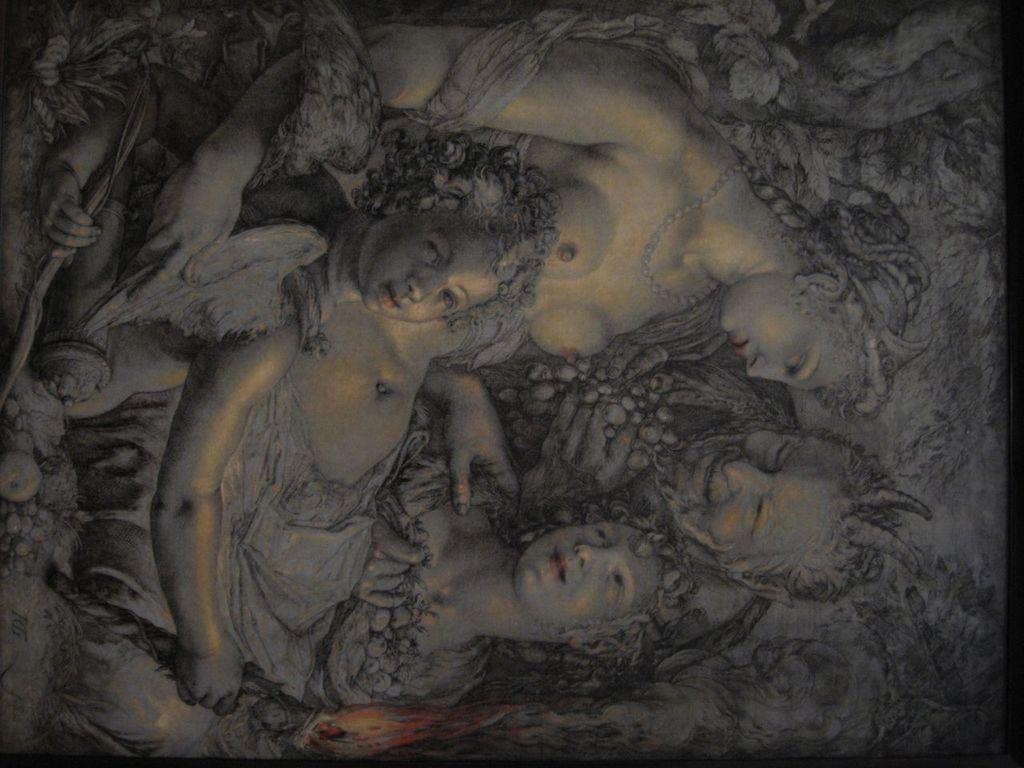What is the main subject of the image? The image contains a painting. What is happening in the painting? The painting depicts four persons. Can you describe the actions of the persons in the painting? There is a person holding an object in the painting. What other elements can be seen in the painting? There is fire and leaves in the painting. What color is the quince in the painting? There is no quince present in the painting; it features four persons, fire, and leaves. How many eyes does the person holding the object have? The image does not provide enough detail to determine the number of eyes the person holding the object has. 